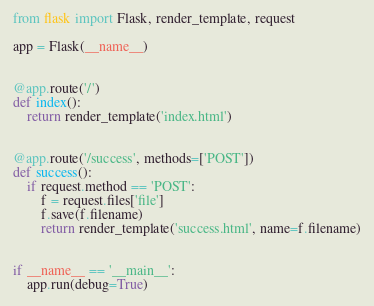<code> <loc_0><loc_0><loc_500><loc_500><_Python_>from flask import Flask, render_template, request

app = Flask(__name__)


@app.route('/')
def index():
    return render_template('index.html')


@app.route('/success', methods=['POST'])
def success():
    if request.method == 'POST':
        f = request.files['file']
        f.save(f.filename)
        return render_template('success.html', name=f.filename)
    

if __name__ == '__main__':
    app.run(debug=True)</code> 